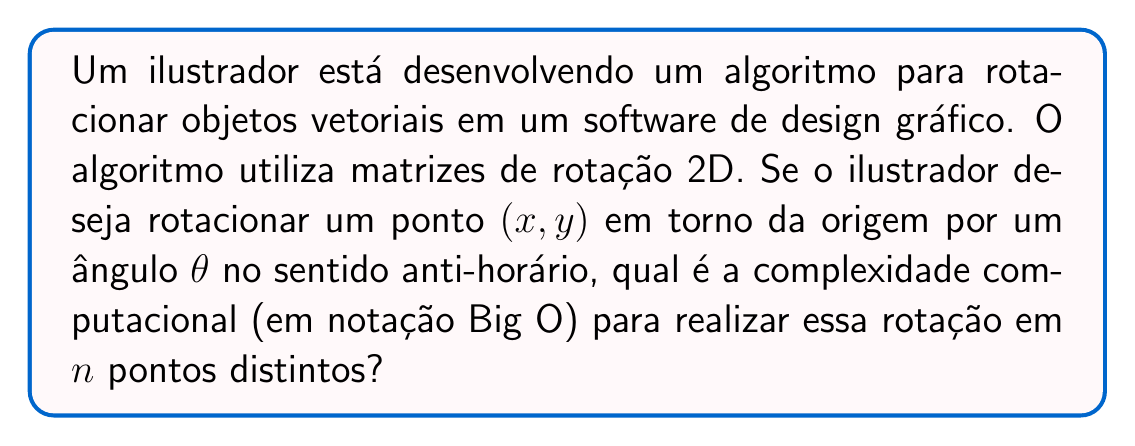Help me with this question. Para resolver este problema, vamos analisar o processo de rotação de um ponto usando uma matriz de rotação 2D:

1. A matriz de rotação 2D para um ângulo $\theta$ é dada por:

   $$R(\theta) = \begin{bmatrix}
   \cos\theta & -\sin\theta \\
   \sin\theta & \cos\theta
   \end{bmatrix}$$

2. Para rotacionar um ponto $(x, y)$, multiplicamos a matriz de rotação pelo vetor do ponto:

   $$\begin{bmatrix}
   x' \\
   y'
   \end{bmatrix} = 
   \begin{bmatrix}
   \cos\theta & -\sin\theta \\
   \sin\theta & \cos\theta
   \end{bmatrix}
   \begin{bmatrix}
   x \\
   y
   \end{bmatrix}$$

3. Esta multiplicação de matriz 2x2 por um vetor 2x1 envolve 4 multiplicações e 2 adições.

4. O cálculo dos valores de $\sin\theta$ e $\cos\theta$ é feito apenas uma vez, independentemente do número de pontos a serem rotacionados.

5. Para cada ponto, realizamos a mesma operação de multiplicação de matriz.

6. Como temos $n$ pontos distintos, repetimos esta operação $n$ vezes.

7. Cada operação de rotação para um único ponto tem complexidade constante $O(1)$, pois envolve um número fixo de operações aritméticas simples.

8. Realizando esta operação $n$ vezes resulta em uma complexidade total de $O(n)$.

Portanto, a complexidade computacional para rotacionar $n$ pontos distintos é $O(n)$, linear em relação ao número de pontos.
Answer: $O(n)$ 